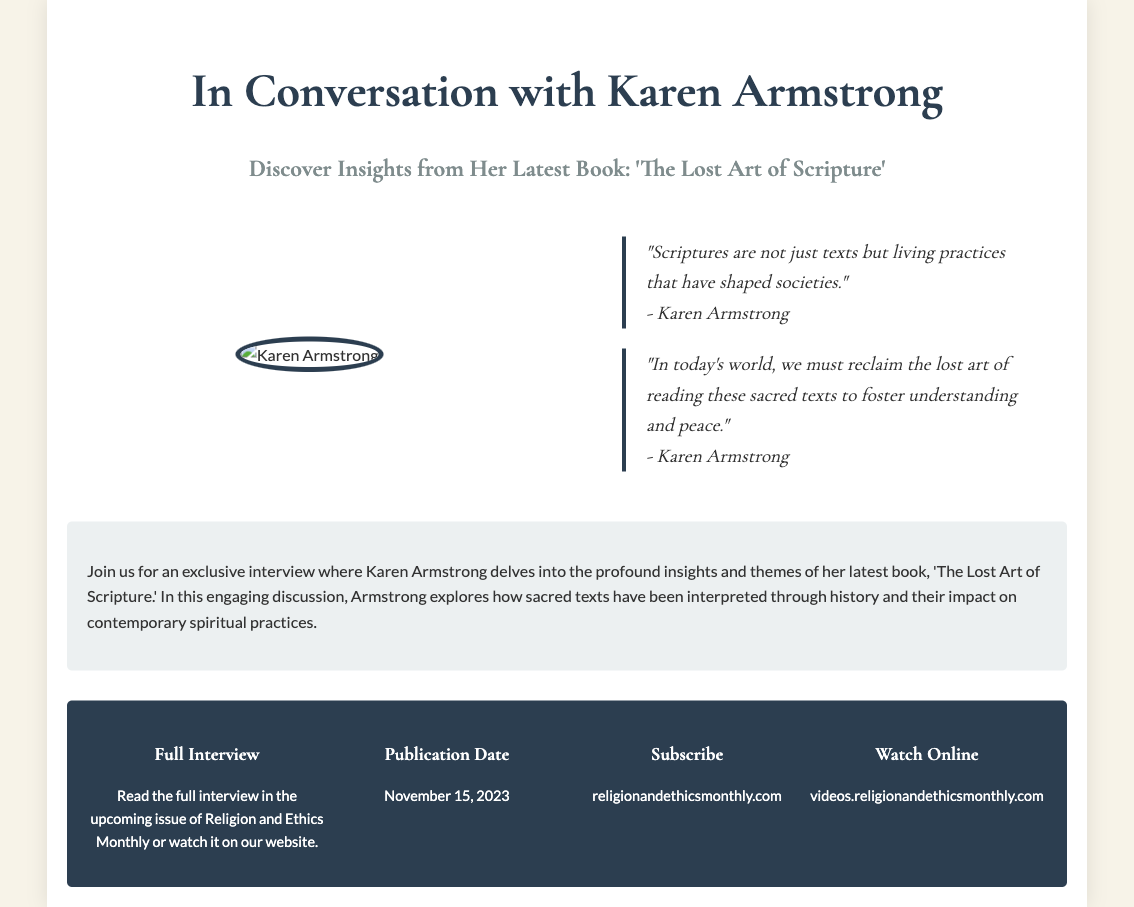What is the name of the author featured in the interview? The author's name is prominently displayed in the header of the advertisement.
Answer: Karen Armstrong What is the title of Karen Armstrong's latest book? The title of the book is mentioned under the author's name in the header.
Answer: The Lost Art of Scripture What are the publication details for the full interview? The publication date and platform for reading the full interview is provided in the details section.
Answer: November 15, 2023 What is one key quote from Karen Armstrong? Quotes are highlighted in the author's section, showcasing the author's perspective.
Answer: "Scriptures are not just texts but living practices that have shaped societies." Where can you watch the full interview online? The location for viewing the full interview is specified in the details section of the document.
Answer: videos.religionandethicsmonthly.com What is the main topic discussed in the interview? The main topic is summarized in the preview section, which provides insight into the interview's focus.
Answer: Sacred texts' interpretation and impact on contemporary spiritual practices 